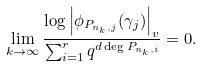Convert formula to latex. <formula><loc_0><loc_0><loc_500><loc_500>\lim _ { k \to \infty } \frac { \log \left | \phi _ { P _ { n _ { k } , j } } ( \gamma _ { j } ) \right | _ { v } } { \sum _ { i = 1 } ^ { r } q ^ { d \deg P _ { n _ { k } , i } } } = 0 .</formula> 